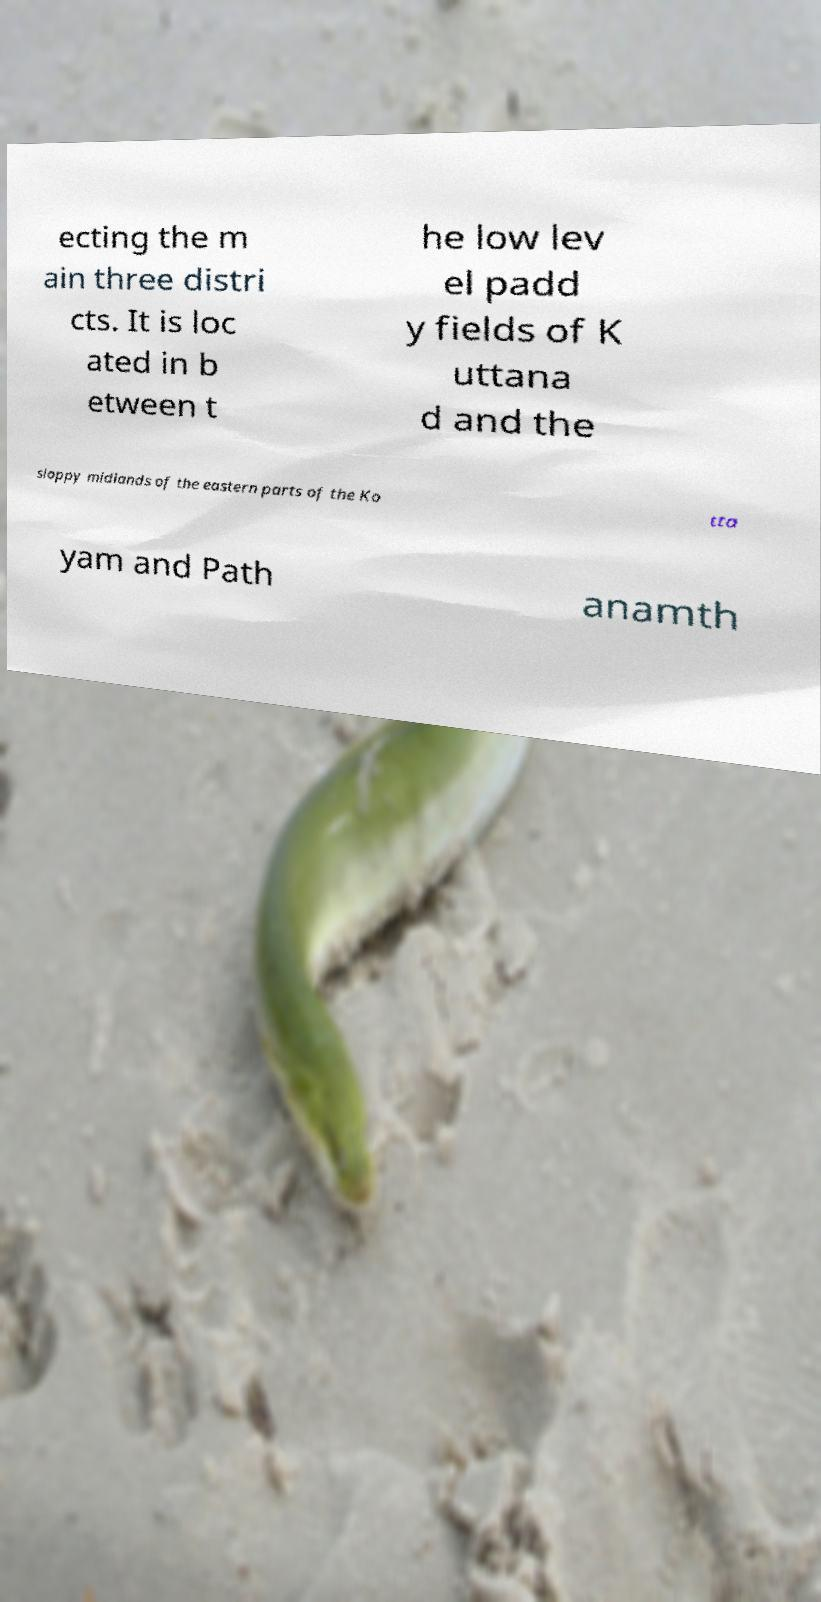What messages or text are displayed in this image? I need them in a readable, typed format. ecting the m ain three distri cts. It is loc ated in b etween t he low lev el padd y fields of K uttana d and the sloppy midlands of the eastern parts of the Ko tta yam and Path anamth 